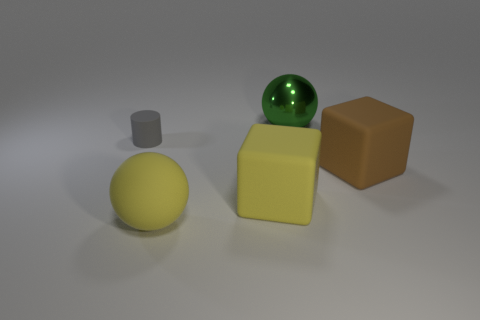Add 3 tiny gray matte cylinders. How many objects exist? 8 Subtract all spheres. How many objects are left? 3 Subtract 0 yellow cylinders. How many objects are left? 5 Subtract all tiny purple rubber balls. Subtract all big brown blocks. How many objects are left? 4 Add 4 matte objects. How many matte objects are left? 8 Add 3 brown rubber things. How many brown rubber things exist? 4 